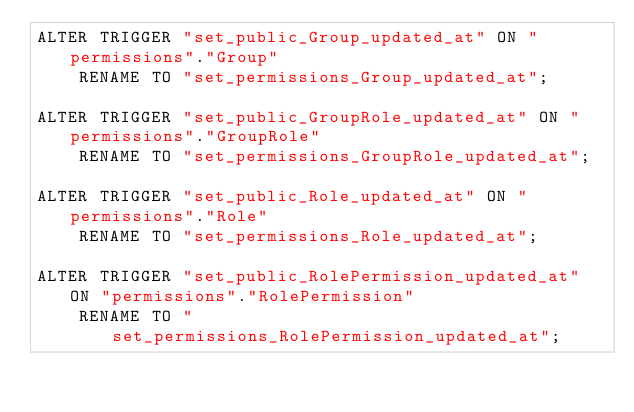Convert code to text. <code><loc_0><loc_0><loc_500><loc_500><_SQL_>ALTER TRIGGER "set_public_Group_updated_at" ON "permissions"."Group"
    RENAME TO "set_permissions_Group_updated_at";

ALTER TRIGGER "set_public_GroupRole_updated_at" ON "permissions"."GroupRole"
    RENAME TO "set_permissions_GroupRole_updated_at";

ALTER TRIGGER "set_public_Role_updated_at" ON "permissions"."Role"
    RENAME TO "set_permissions_Role_updated_at";

ALTER TRIGGER "set_public_RolePermission_updated_at" ON "permissions"."RolePermission"
    RENAME TO "set_permissions_RolePermission_updated_at";
</code> 